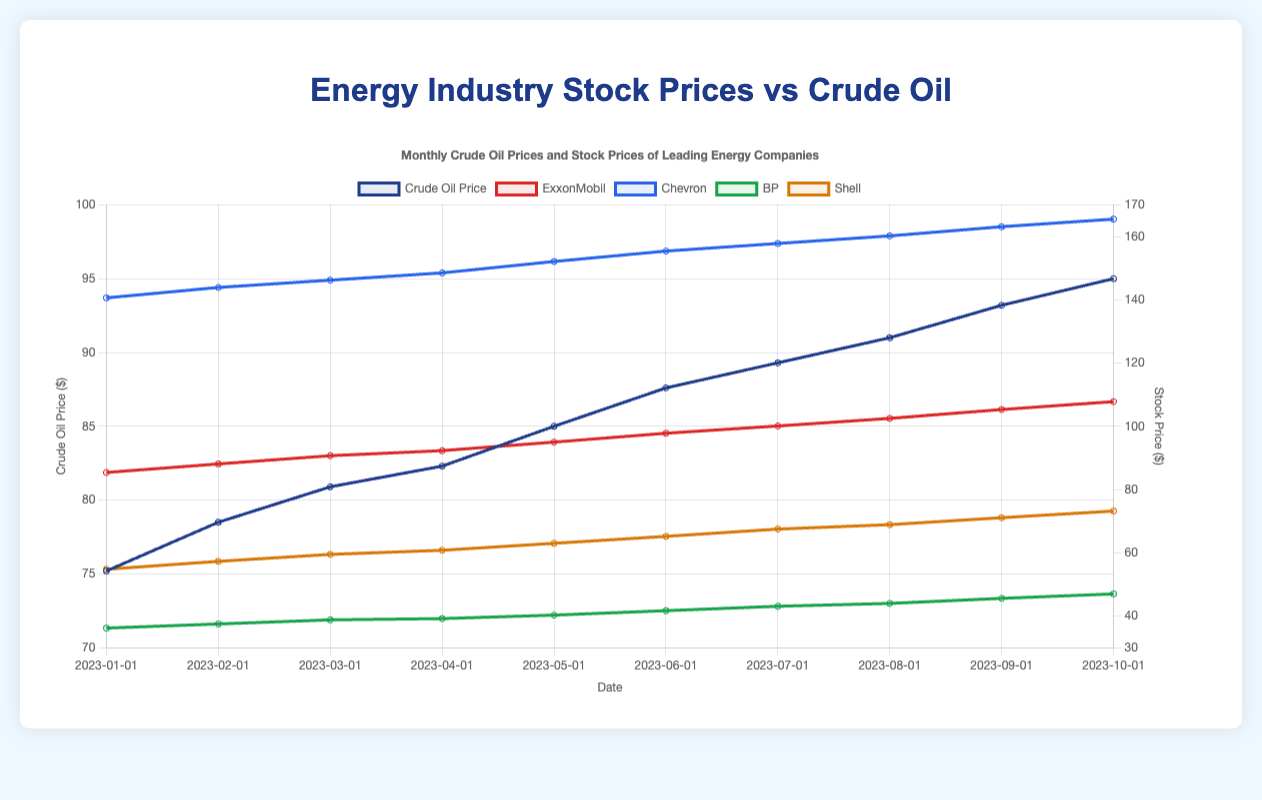What is the overall trend of crude oil prices from January 2023 to October 2023? From January to October 2023, the plot shows a consistent upward trend in crude oil prices, starting at around $75.2 and reaching $95.0 by October. Each data point reveals an increase in price over time.
Answer: Increasing How does the stock price of ExxonMobil in October 2023 compare with the stock price of BP in the same month? In October 2023, ExxonMobil's stock price is approximately $107.8, whereas BP’s stock price is around $47.0. By comparing these values directly, ExxonMobil’s stock price is higher.
Answer: ExxonMobil's stock price is higher Which company exhibited the highest stock price in October 2023, and what was that price? By observing the plot, Chevron exhibited the highest stock price in October 2023, reaching about $165.5. This is determined by comparing all the plotted stock prices for that month.
Answer: Chevron, $165.5 What is the average crude oil price over the period from January 2023 to October 2023? First, sum the crude oil prices for each month from January through October: (75.2 + 78.5 + 80.9 + 82.3 + 85.0 + 87.6 + 89.3 + 91.0 + 93.2 + 95.0). Then divide by the total number of months (10). The average crude oil price is 85.8.
Answer: $85.8 Between January and October 2023, which month had the lowest stock price for BP, and what was the price? Looking at the plot, BP's stock price was the lowest in January 2023, at approximately $36.2. This is identified by reviewing each data point for BP and finding the minimum value.
Answer: January 2023, $36.2 How did the stock prices of Shell change from August 2023 to September 2023? Shell’s stock price in August 2023 was around $68.9, and it rose to approximately $71.1 in September 2023. The difference between these two points indicates an increase of $2.2 in the stock price.
Answer: Increased by $2.2 What is the combined difference in stock prices between January 2023 and October 2023 for Chevron and ExxonMobil? Chevron's stock price increased from $140.6 in January to $165.5 in October, which is a difference of $24.9. ExxonMobil's stock price increased from $85.4 to $107.8, a difference of $22.4. The combined difference is $24.9 + $22.4 = $47.3.
Answer: $47.3 How do the stock price trends of Chevron and Shell compare from January 2023 to October 2023? Both Chevron and Shell show an upward trend in their stock prices. Chevron starts at $140.6 and ends at $165.5, while Shell starts at $54.8 and ends at $73.2. Both companies demonstrate an increase, but Chevron's growth is both in absolute terms and the overall value higher.
Answer: Both increase, Chevron shows higher growth 